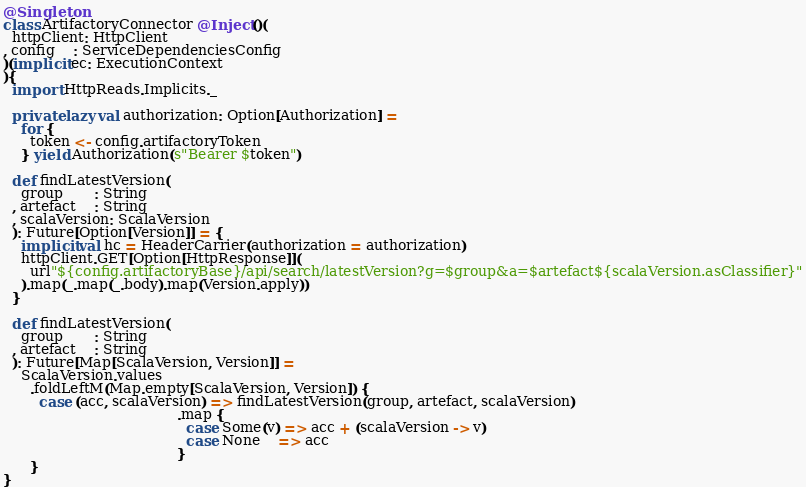<code> <loc_0><loc_0><loc_500><loc_500><_Scala_>@Singleton
class ArtifactoryConnector @Inject()(
  httpClient: HttpClient
, config    : ServiceDependenciesConfig
)(implicit ec: ExecutionContext
){
  import HttpReads.Implicits._

  private lazy val authorization: Option[Authorization] =
    for {
      token <- config.artifactoryToken
    } yield Authorization(s"Bearer $token")

  def findLatestVersion(
    group       : String
  , artefact    : String
  , scalaVersion: ScalaVersion
  ): Future[Option[Version]] = {
    implicit val hc = HeaderCarrier(authorization = authorization)
    httpClient.GET[Option[HttpResponse]](
      url"${config.artifactoryBase}/api/search/latestVersion?g=$group&a=$artefact${scalaVersion.asClassifier}"
    ).map(_.map(_.body).map(Version.apply))
  }

  def findLatestVersion(
    group       : String
  , artefact    : String
  ): Future[Map[ScalaVersion, Version]] =
    ScalaVersion.values
      .foldLeftM(Map.empty[ScalaVersion, Version]) {
        case (acc, scalaVersion) => findLatestVersion(group, artefact, scalaVersion)
                                       .map {
                                         case Some(v) => acc + (scalaVersion -> v)
                                         case None    => acc
                                       }
      }
}
</code> 